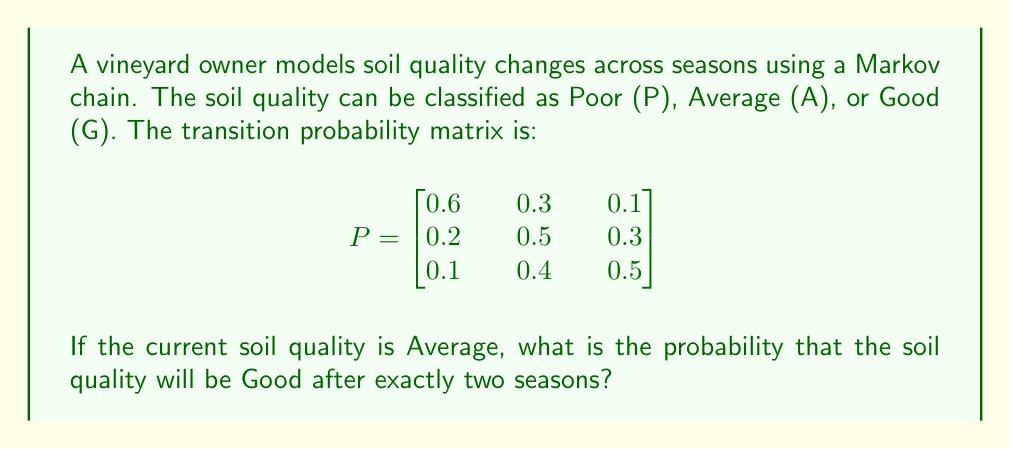Can you answer this question? To solve this problem, we need to use the Chapman-Kolmogorov equations and matrix multiplication:

1) The initial state vector for Average soil quality is:
   $$v_0 = \begin{bmatrix} 0 & 1 & 0 \end{bmatrix}$$

2) We need to calculate $P^2$ (the transition matrix after two steps):
   $$P^2 = P \times P = \begin{bmatrix}
   0.6 & 0.3 & 0.1 \\
   0.2 & 0.5 & 0.3 \\
   0.1 & 0.4 & 0.5
   \end{bmatrix} \times \begin{bmatrix}
   0.6 & 0.3 & 0.1 \\
   0.2 & 0.5 & 0.3 \\
   0.1 & 0.4 & 0.5
   \end{bmatrix}$$

3) Performing the matrix multiplication:
   $$P^2 = \begin{bmatrix}
   0.42 & 0.39 & 0.19 \\
   0.23 & 0.46 & 0.31 \\
   0.17 & 0.44 & 0.39
   \end{bmatrix}$$

4) The probability of transitioning from Average to Good after two seasons is the element in the second row, third column of $P^2$:
   $$P(X_2 = G | X_0 = A) = 0.31$$
Answer: 0.31 